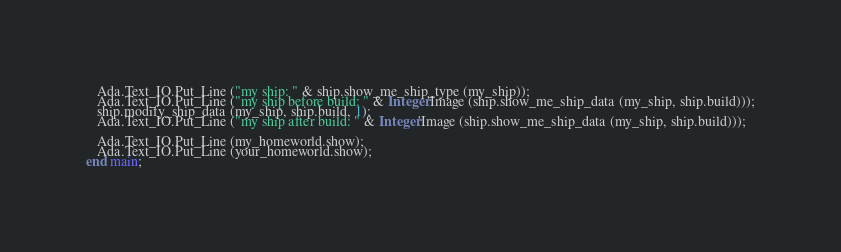Convert code to text. <code><loc_0><loc_0><loc_500><loc_500><_Ada_>   Ada.Text_IO.Put_Line ("my ship: " & ship.show_me_ship_type (my_ship));
   Ada.Text_IO.Put_Line ("my ship before build: " & Integer'Image (ship.show_me_ship_data (my_ship, ship.build)));
   ship.modify_ship_data (my_ship, ship.build, 1);
   Ada.Text_IO.Put_Line ("my ship after build: " & Integer'Image (ship.show_me_ship_data (my_ship, ship.build)));

   Ada.Text_IO.Put_Line (my_homeworld.show);
   Ada.Text_IO.Put_Line (your_homeworld.show);
end main;
</code> 